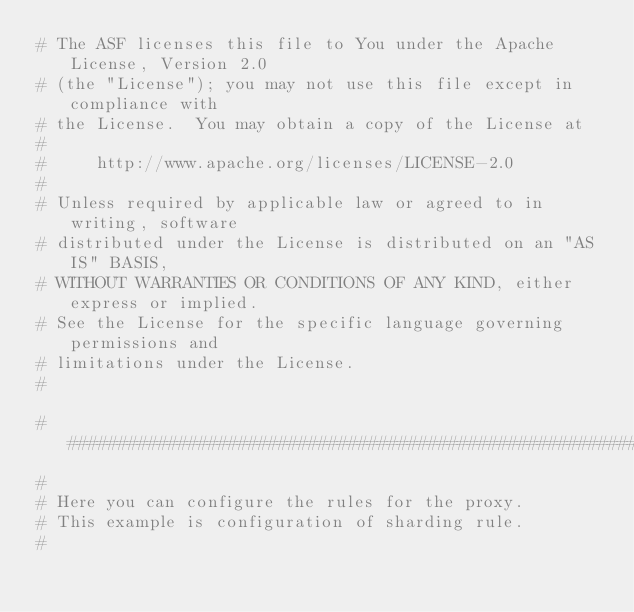Convert code to text. <code><loc_0><loc_0><loc_500><loc_500><_YAML_># The ASF licenses this file to You under the Apache License, Version 2.0
# (the "License"); you may not use this file except in compliance with
# the License.  You may obtain a copy of the License at
#
#     http://www.apache.org/licenses/LICENSE-2.0
#
# Unless required by applicable law or agreed to in writing, software
# distributed under the License is distributed on an "AS IS" BASIS,
# WITHOUT WARRANTIES OR CONDITIONS OF ANY KIND, either express or implied.
# See the License for the specific language governing permissions and
# limitations under the License.
#

######################################################################################################
# 
# Here you can configure the rules for the proxy.
# This example is configuration of sharding rule.
#   </code> 